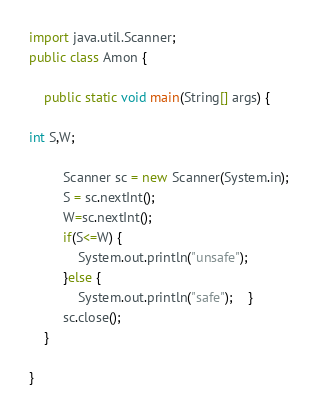<code> <loc_0><loc_0><loc_500><loc_500><_Java_>import java.util.Scanner;
public class Amon {

	public static void main(String[] args) {
	
int S,W;

	     Scanner sc = new Scanner(System.in);
	     S = sc.nextInt();
	     W=sc.nextInt();
	     if(S<=W) {
	    	 System.out.println("unsafe");	
	     }else {
	    	 System.out.println("safe");	}
	     sc.close();
	}

}
</code> 